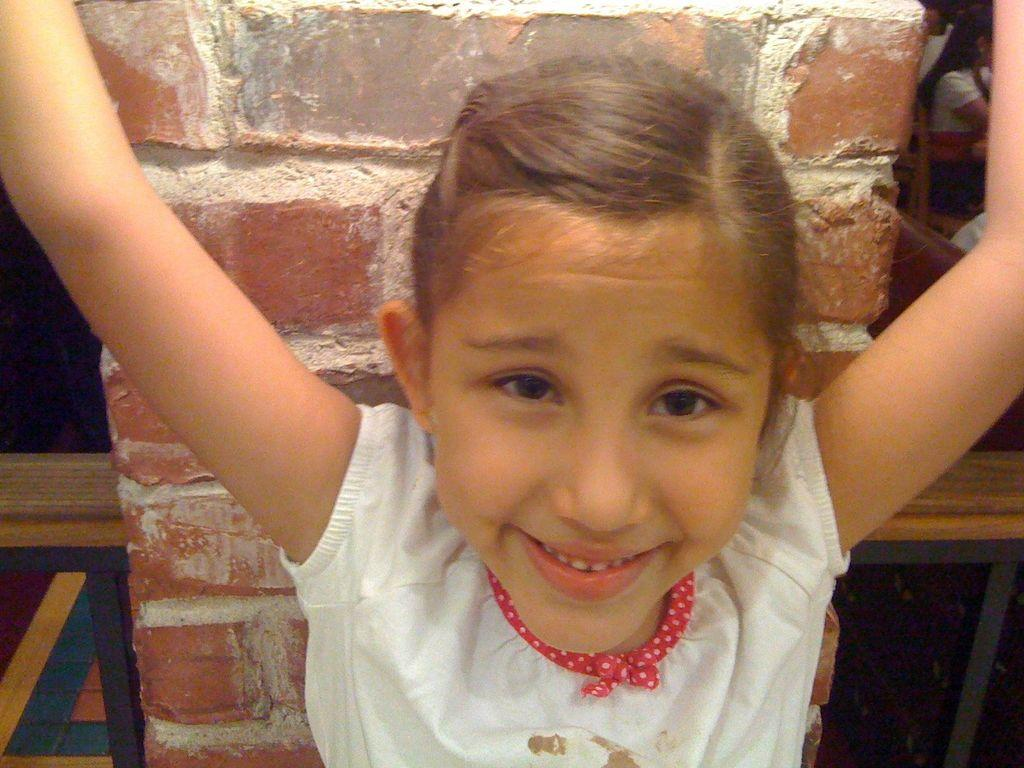What is the main subject of the image? There is a kid in the center of the image. What can be seen in the background of the image? There is a wall and other people visible in the background. Are there any objects or structures in the background? Yes, there are benches in the background. How far can the chairs in the image be seen? There are no chairs present in the image, so it is not possible to determine how far they can be seen. 